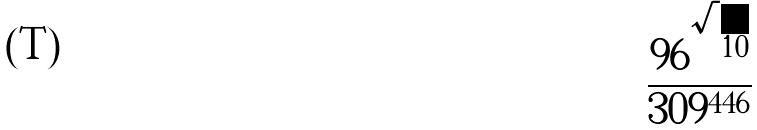<formula> <loc_0><loc_0><loc_500><loc_500>\frac { 9 6 ^ { \sqrt { 1 0 } } } { 3 0 9 ^ { 4 4 6 } }</formula> 